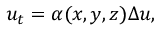<formula> <loc_0><loc_0><loc_500><loc_500>u _ { t } = \alpha ( x , y , z ) \Delta u ,</formula> 